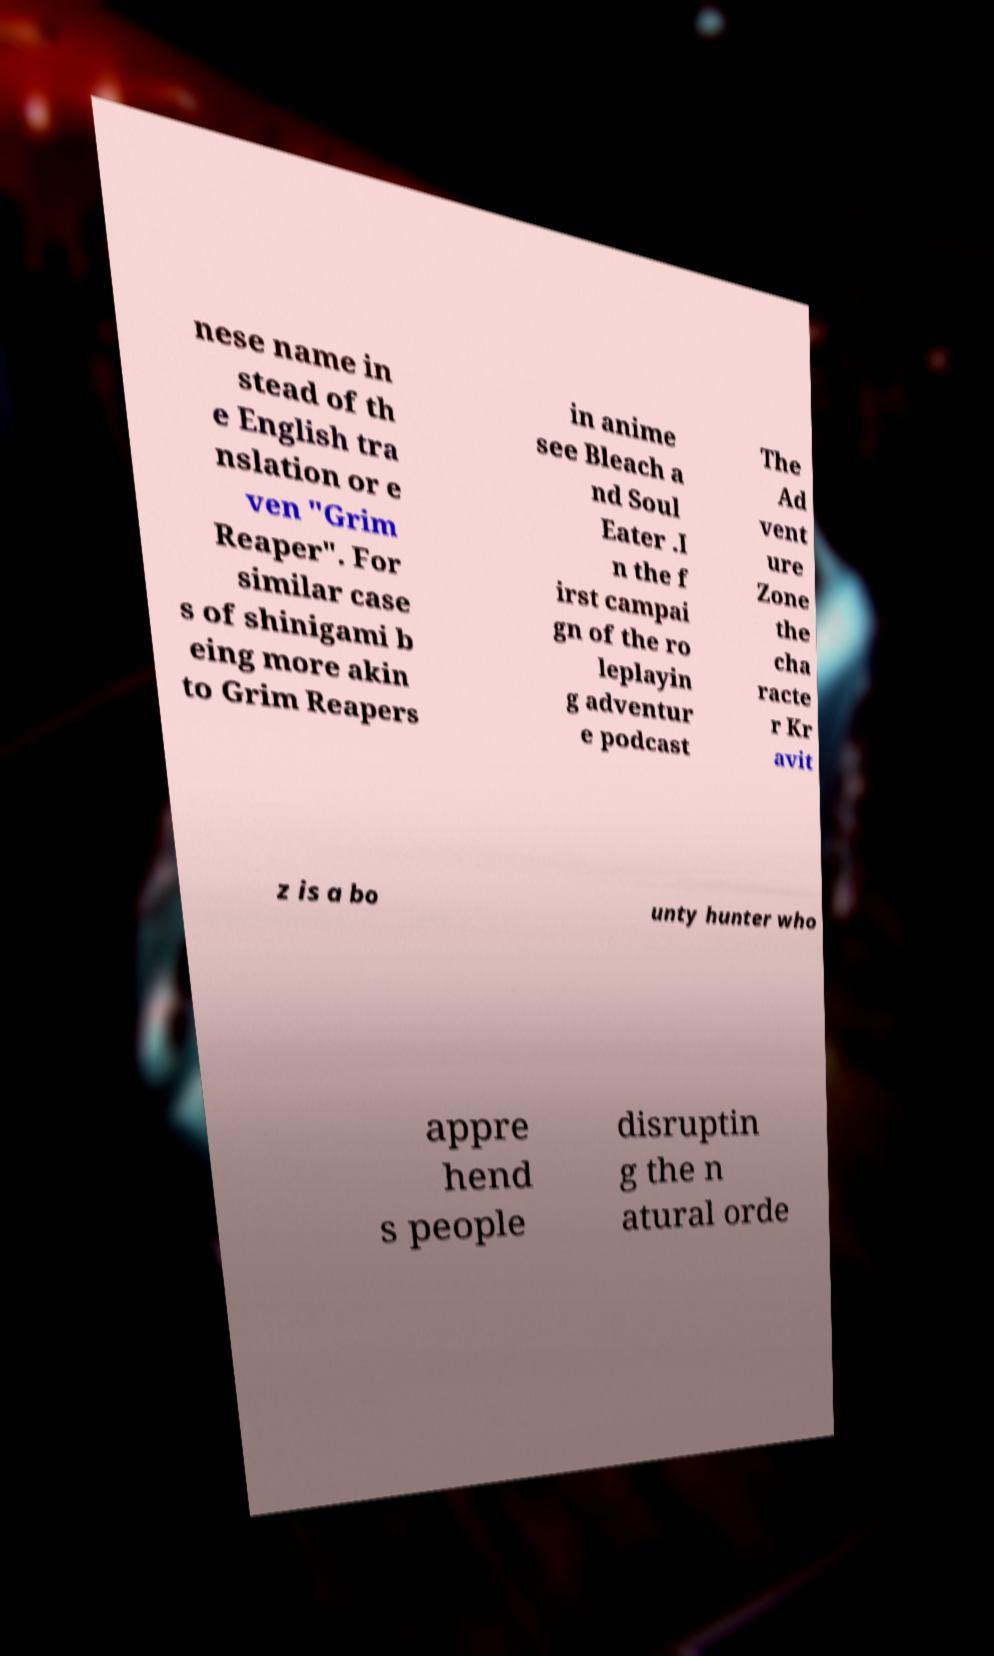Could you assist in decoding the text presented in this image and type it out clearly? nese name in stead of th e English tra nslation or e ven "Grim Reaper". For similar case s of shinigami b eing more akin to Grim Reapers in anime see Bleach a nd Soul Eater .I n the f irst campai gn of the ro leplayin g adventur e podcast The Ad vent ure Zone the cha racte r Kr avit z is a bo unty hunter who appre hend s people disruptin g the n atural orde 